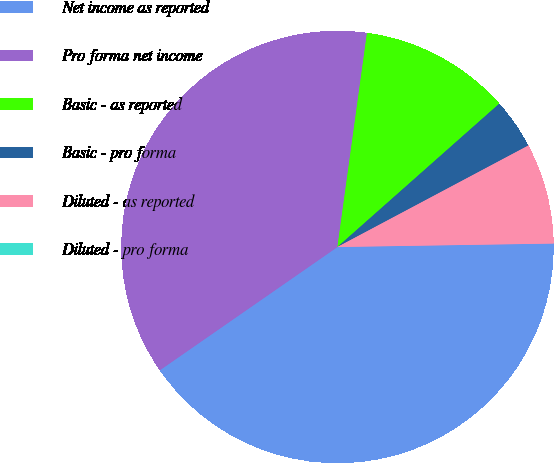Convert chart to OTSL. <chart><loc_0><loc_0><loc_500><loc_500><pie_chart><fcel>Net income as reported<fcel>Pro forma net income<fcel>Basic - as reported<fcel>Basic - pro forma<fcel>Diluted - as reported<fcel>Diluted - pro forma<nl><fcel>40.6%<fcel>36.84%<fcel>11.28%<fcel>3.76%<fcel>7.52%<fcel>0.0%<nl></chart> 